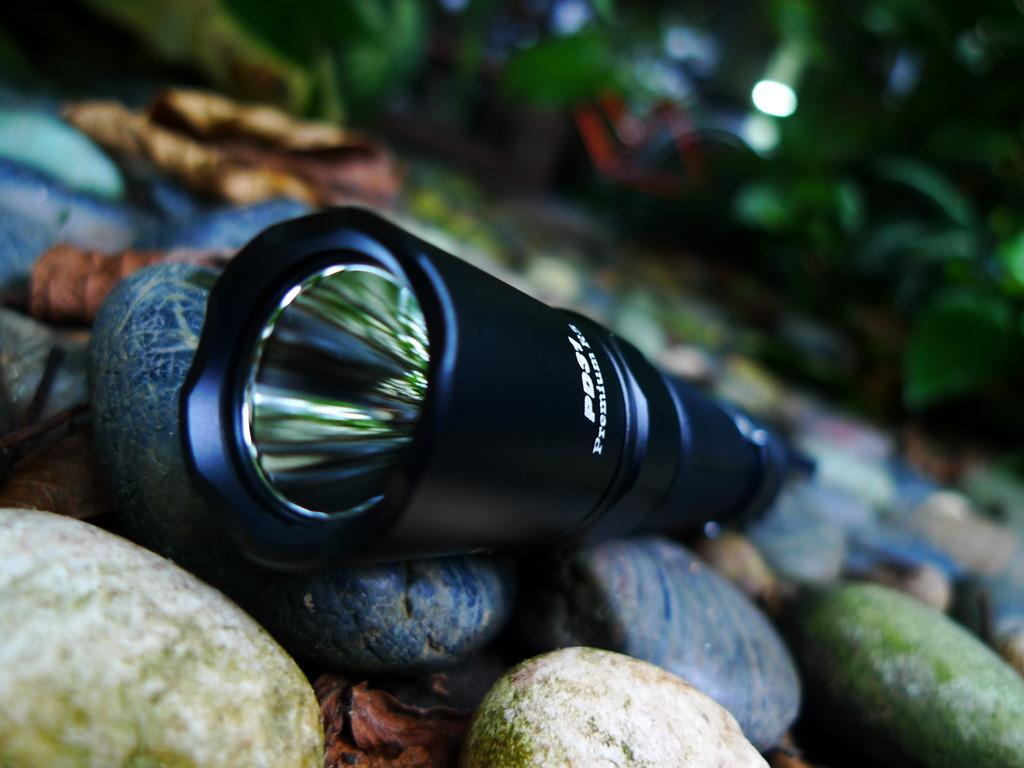What object is present on the rocks in the image? There is a torch on the rocks in the image. What is the color of the torch? The torch is black in color. What can be found at the bottom of the image? There are rocks at the bottom of the image. What type of vegetation is visible in the background of the image? There are plants in the background of the image. What is the name of the mist that can be seen surrounding the torch in the image? There is no mist present in the image; it only features a torch on rocks, with plants in the background. 